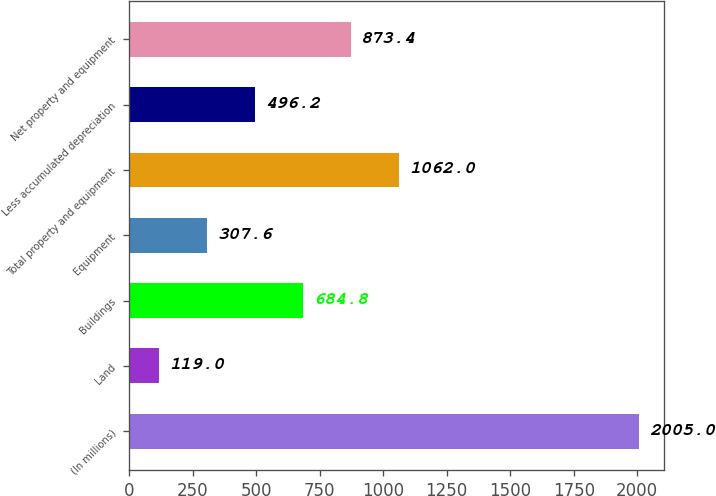Convert chart. <chart><loc_0><loc_0><loc_500><loc_500><bar_chart><fcel>(In millions)<fcel>Land<fcel>Buildings<fcel>Equipment<fcel>Total property and equipment<fcel>Less accumulated depreciation<fcel>Net property and equipment<nl><fcel>2005<fcel>119<fcel>684.8<fcel>307.6<fcel>1062<fcel>496.2<fcel>873.4<nl></chart> 